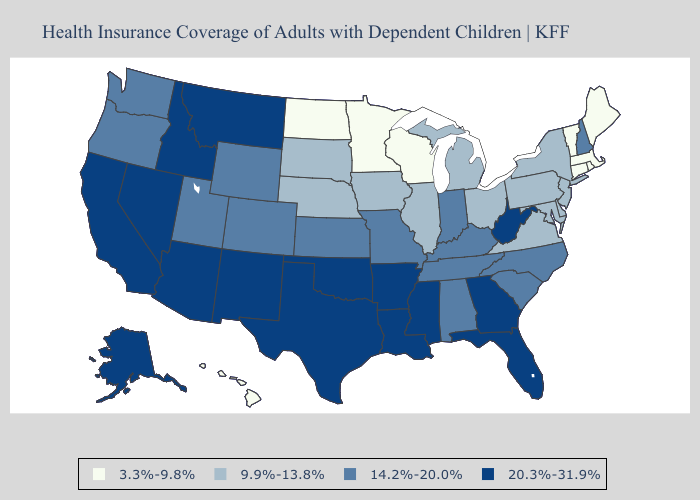Among the states that border Iowa , which have the highest value?
Give a very brief answer. Missouri. Name the states that have a value in the range 20.3%-31.9%?
Keep it brief. Alaska, Arizona, Arkansas, California, Florida, Georgia, Idaho, Louisiana, Mississippi, Montana, Nevada, New Mexico, Oklahoma, Texas, West Virginia. What is the highest value in the USA?
Concise answer only. 20.3%-31.9%. What is the highest value in states that border Iowa?
Quick response, please. 14.2%-20.0%. Does Illinois have a higher value than Massachusetts?
Short answer required. Yes. Name the states that have a value in the range 3.3%-9.8%?
Be succinct. Connecticut, Hawaii, Maine, Massachusetts, Minnesota, North Dakota, Rhode Island, Vermont, Wisconsin. Does South Carolina have the lowest value in the USA?
Write a very short answer. No. What is the lowest value in the Northeast?
Concise answer only. 3.3%-9.8%. What is the value of Florida?
Keep it brief. 20.3%-31.9%. Does the first symbol in the legend represent the smallest category?
Keep it brief. Yes. Does Delaware have the lowest value in the South?
Be succinct. Yes. Does Alaska have the highest value in the West?
Concise answer only. Yes. What is the value of Colorado?
Quick response, please. 14.2%-20.0%. Which states hav the highest value in the West?
Quick response, please. Alaska, Arizona, California, Idaho, Montana, Nevada, New Mexico. What is the value of Maine?
Be succinct. 3.3%-9.8%. 